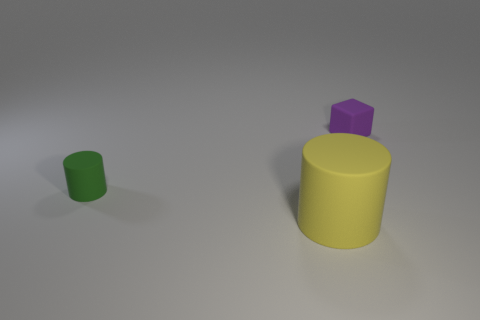Add 2 big brown metal objects. How many objects exist? 5 Subtract all cylinders. How many objects are left? 1 Add 1 tiny green spheres. How many tiny green spheres exist? 1 Subtract 1 yellow cylinders. How many objects are left? 2 Subtract all tiny blue blocks. Subtract all small things. How many objects are left? 1 Add 2 cylinders. How many cylinders are left? 4 